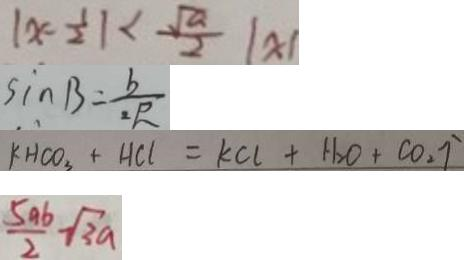<formula> <loc_0><loc_0><loc_500><loc_500>\vert x - \frac { 1 } { 2 } \vert < \frac { \sqrt { a } } { 2 } \vert x \vert 
 \sin B = \frac { b } { 2 R } 
 k H C O _ { 3 } + H C l = k C l + H _ { 2 } O + C O _ { 2 } \uparrow 
 \frac { 5 a b } { 2 } - \sqrt { 3 a }</formula> 